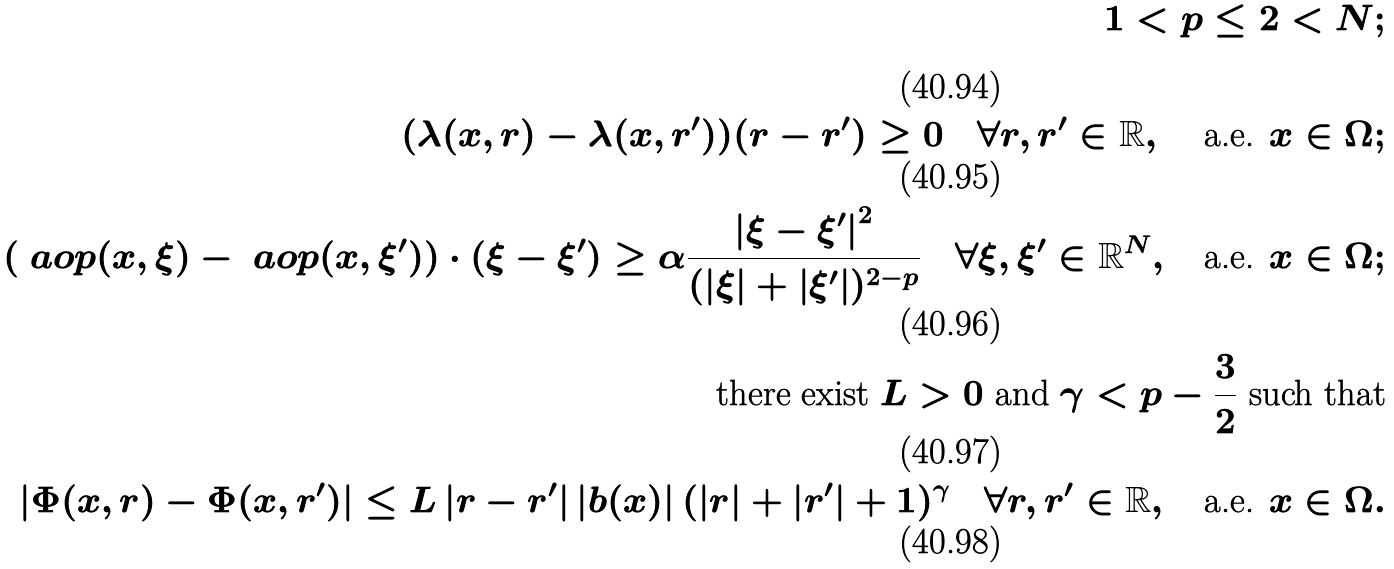Convert formula to latex. <formula><loc_0><loc_0><loc_500><loc_500>1 < p \leq 2 < N ; \\ ( \lambda ( x , r ) - \lambda ( x , r ^ { \prime } ) ) ( r - r ^ { \prime } ) \geq 0 \quad \forall r , r ^ { \prime } \in \mathbb { R } , \, \quad \text {a.e. } x \in \Omega ; \\ ( \ a o p ( x , \xi ) - \ a o p ( x , \xi ^ { \prime } ) ) \cdot ( \xi - \xi ^ { \prime } ) \geq \alpha \frac { \left | \xi - \xi ^ { \prime } \right | ^ { 2 } } { ( \left | \xi \right | + \left | \xi ^ { \prime } \right | ) ^ { 2 - p } } \quad \forall \xi , \xi ^ { \prime } \in \mathbb { R } ^ { N } , \quad \text {a.e. } x \in \Omega ; \\ \text {there exist } L > 0 \text { and } \gamma < p - \frac { 3 } { 2 } \text { such that} \\ \left | \Phi ( x , r ) - \Phi ( x , r ^ { \prime } ) \right | \leq L \left | r - r ^ { \prime } \right | \left | b ( x ) \right | ( \left | r \right | + \left | r ^ { \prime } \right | + 1 ) ^ { \gamma } \quad \forall r , r ^ { \prime } \in \mathbb { R } , \quad \text {a.e. } x \in \Omega .</formula> 